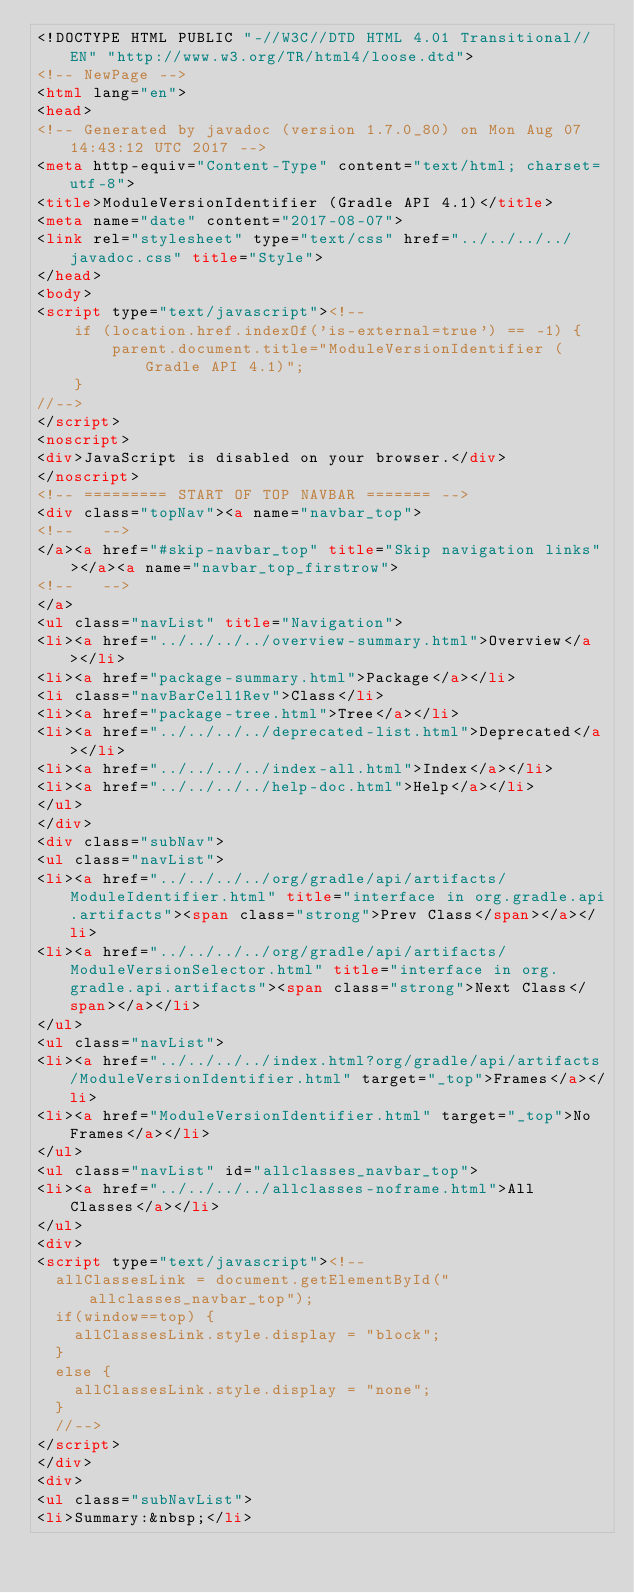<code> <loc_0><loc_0><loc_500><loc_500><_HTML_><!DOCTYPE HTML PUBLIC "-//W3C//DTD HTML 4.01 Transitional//EN" "http://www.w3.org/TR/html4/loose.dtd">
<!-- NewPage -->
<html lang="en">
<head>
<!-- Generated by javadoc (version 1.7.0_80) on Mon Aug 07 14:43:12 UTC 2017 -->
<meta http-equiv="Content-Type" content="text/html; charset=utf-8">
<title>ModuleVersionIdentifier (Gradle API 4.1)</title>
<meta name="date" content="2017-08-07">
<link rel="stylesheet" type="text/css" href="../../../../javadoc.css" title="Style">
</head>
<body>
<script type="text/javascript"><!--
    if (location.href.indexOf('is-external=true') == -1) {
        parent.document.title="ModuleVersionIdentifier (Gradle API 4.1)";
    }
//-->
</script>
<noscript>
<div>JavaScript is disabled on your browser.</div>
</noscript>
<!-- ========= START OF TOP NAVBAR ======= -->
<div class="topNav"><a name="navbar_top">
<!--   -->
</a><a href="#skip-navbar_top" title="Skip navigation links"></a><a name="navbar_top_firstrow">
<!--   -->
</a>
<ul class="navList" title="Navigation">
<li><a href="../../../../overview-summary.html">Overview</a></li>
<li><a href="package-summary.html">Package</a></li>
<li class="navBarCell1Rev">Class</li>
<li><a href="package-tree.html">Tree</a></li>
<li><a href="../../../../deprecated-list.html">Deprecated</a></li>
<li><a href="../../../../index-all.html">Index</a></li>
<li><a href="../../../../help-doc.html">Help</a></li>
</ul>
</div>
<div class="subNav">
<ul class="navList">
<li><a href="../../../../org/gradle/api/artifacts/ModuleIdentifier.html" title="interface in org.gradle.api.artifacts"><span class="strong">Prev Class</span></a></li>
<li><a href="../../../../org/gradle/api/artifacts/ModuleVersionSelector.html" title="interface in org.gradle.api.artifacts"><span class="strong">Next Class</span></a></li>
</ul>
<ul class="navList">
<li><a href="../../../../index.html?org/gradle/api/artifacts/ModuleVersionIdentifier.html" target="_top">Frames</a></li>
<li><a href="ModuleVersionIdentifier.html" target="_top">No Frames</a></li>
</ul>
<ul class="navList" id="allclasses_navbar_top">
<li><a href="../../../../allclasses-noframe.html">All Classes</a></li>
</ul>
<div>
<script type="text/javascript"><!--
  allClassesLink = document.getElementById("allclasses_navbar_top");
  if(window==top) {
    allClassesLink.style.display = "block";
  }
  else {
    allClassesLink.style.display = "none";
  }
  //-->
</script>
</div>
<div>
<ul class="subNavList">
<li>Summary:&nbsp;</li></code> 